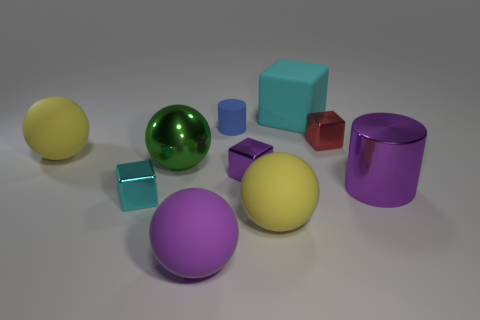What number of tiny objects are on the left side of the small red thing and right of the big rubber cube?
Your answer should be very brief. 0. Is the number of blue objects in front of the red metallic block less than the number of matte cubes behind the blue matte cylinder?
Your answer should be compact. Yes. Do the tiny blue matte object and the large purple metal thing have the same shape?
Your answer should be compact. Yes. What number of other objects are there of the same size as the blue rubber cylinder?
Your answer should be compact. 3. How many objects are large green metallic balls that are left of the tiny cylinder or matte objects that are to the left of the tiny purple shiny block?
Make the answer very short. 4. How many large yellow objects have the same shape as the small cyan metallic thing?
Your response must be concise. 0. What is the thing that is in front of the purple shiny block and to the left of the green metallic object made of?
Ensure brevity in your answer.  Metal. There is a tiny purple cube; how many tiny metal objects are behind it?
Your response must be concise. 1. How many things are there?
Give a very brief answer. 10. Does the purple metallic cylinder have the same size as the purple matte thing?
Your answer should be very brief. Yes. 